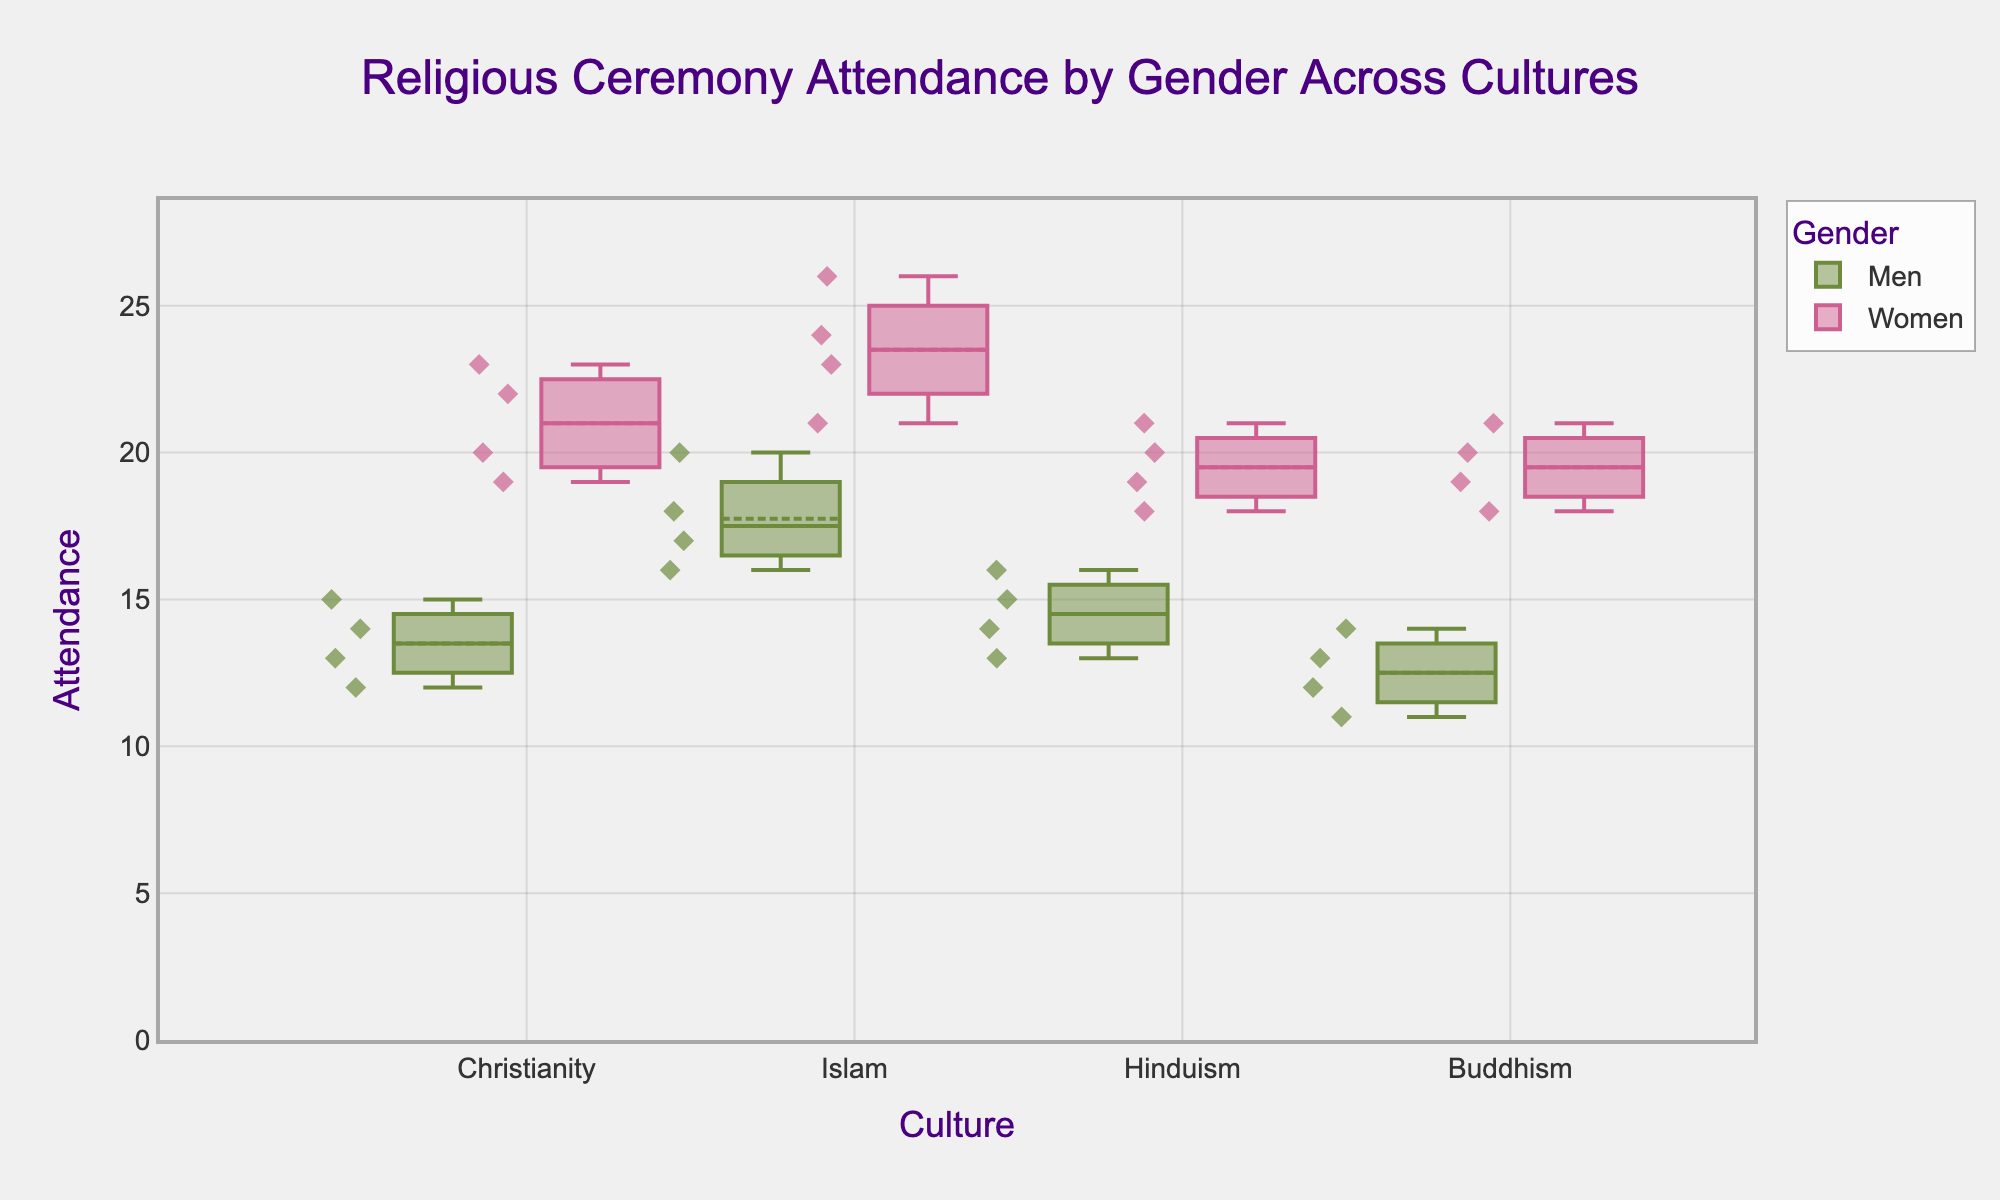What's the title of the plot? The title is located at the top center of the figure and usually describes the main topic of the chart. In this case, it reads "Religious Ceremony Attendance by Gender Across Cultures."
Answer: Religious Ceremony Attendance by Gender Across Cultures What are the cultures represented in the plot? The cultures are listed along the x-axis of the plot and include all the distinct categories. Here, they are Christianity, Islam, Hinduism, and Buddhism.
Answer: Christianity, Islam, Hinduism, and Buddhism Which gender has the highest median attendance across all cultures? Look at the median line (middle line) within the boxes for each gender across all cultures. For both genders in each culture, compare these median lines. Women consistently have a higher median attendance compared to men.
Answer: Women What is the median attendance for Men in Islam? Identify the box plot for Men within the Islam category and locate the median line within the box. The median line appears to be at 18.
Answer: 18 Which two cultures exhibit the largest difference in median attendance for Women? Compare the median lines in the boxes representing Women across different cultures. The largest difference can be observed between Buddhism and Christianity.
Answer: Buddhism and Christianity Which culture shows the most similar attendance patterns between Men and Women? Look for the culture where the boxes for Men and Women overlap the most in terms of their spread and medians. Hinduism shows the most similar patterns with medians both around 15-20.
Answer: Hinduism What is the highest attendance recorded for Men in any culture and what culture is it? Look for the highest points or the top whisker ends in the boxes for Men. The highest attendance for Men appears in Islam, reaching 20.
Answer: 20, Islam What is the interquartile range (IQR) for Women's attendance in Christianity? IQR is calculated as the difference between the third (upper) quartile and the first (lower) quartile within the box. For Women in Christianity, visually estimate these values as 20 and 23, so IQR = 23 - 20 = 3.
Answer: 3 Which culture shows the highest variability in attendance for Women? Variability can be inferred from the height of the boxes and the length of the whiskers. Islam shows the highest variability in Women’s attendance, indicated by a tall box and long whiskers.
Answer: Islam Is there any overlap in attendance ranges between Men and Women in Buddhism? Items overlap if the top whisker of Men goes above the bottom whisker of Women or vice versa. In Buddhism, the highest point for Men is 14 and the lowest for Women is 18, showing no overlap.
Answer: No 